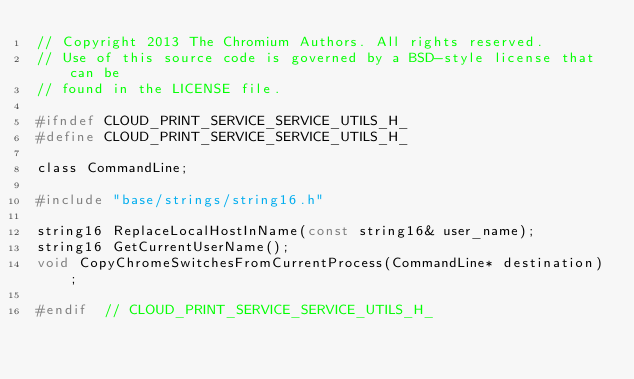Convert code to text. <code><loc_0><loc_0><loc_500><loc_500><_C_>// Copyright 2013 The Chromium Authors. All rights reserved.
// Use of this source code is governed by a BSD-style license that can be
// found in the LICENSE file.

#ifndef CLOUD_PRINT_SERVICE_SERVICE_UTILS_H_
#define CLOUD_PRINT_SERVICE_SERVICE_UTILS_H_

class CommandLine;

#include "base/strings/string16.h"

string16 ReplaceLocalHostInName(const string16& user_name);
string16 GetCurrentUserName();
void CopyChromeSwitchesFromCurrentProcess(CommandLine* destination);

#endif  // CLOUD_PRINT_SERVICE_SERVICE_UTILS_H_

</code> 